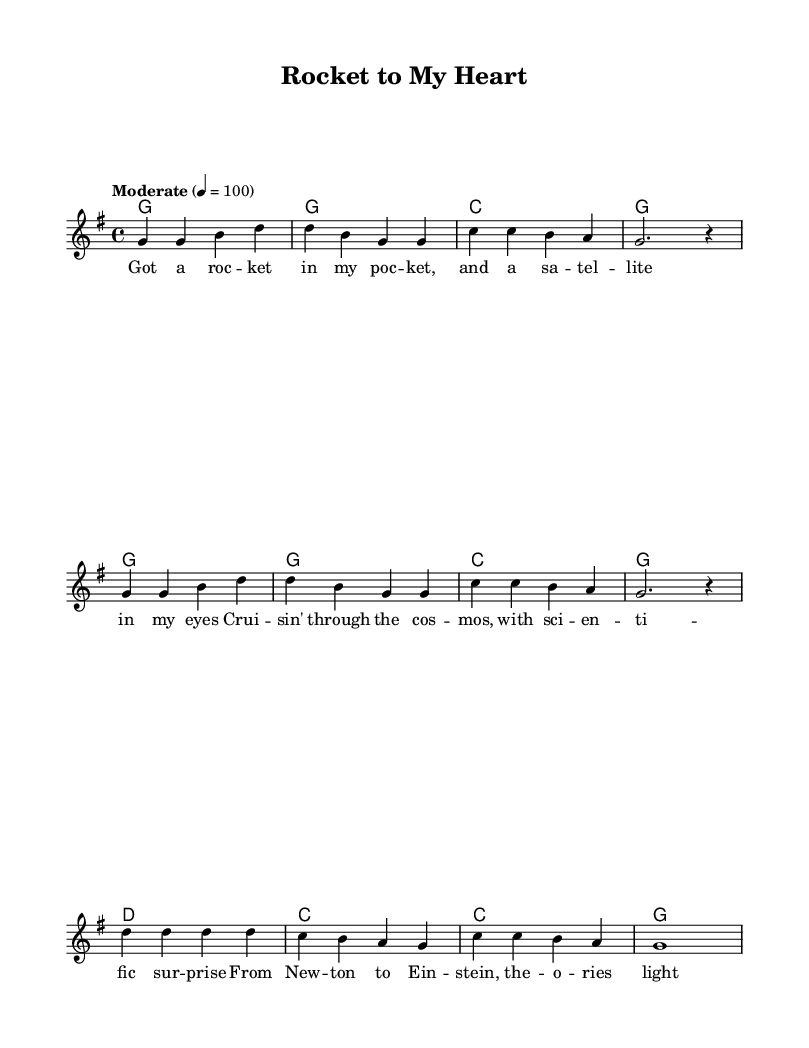What is the key signature of this music? The key signature is G major, as indicated by the presence of one sharp (F#) at the beginning of the score.
Answer: G major What is the time signature of the music? The time signature is 4/4, denoting that there are four beats in each measure and the quarter note gets one beat, which is shown in the second measure of the score.
Answer: 4/4 What is the tempo marking for the song? The tempo marking at the beginning of the score indicates "Moderate" with a metronome marking of 100 beats per minute. This guides the performer on the speed of the music.
Answer: Moderate 4 = 100 How many measures are in the melody? The melody consists of a total of 8 measures, as counted by the distinct sets of musical notes and rests laid out across the score.
Answer: 8 measures What is the lyrical theme of the first verse? The lyrics contain themes of space travel and scientific discovery, as suggested by lines mentioning a "rocket," "satellite," and references to famous scientists.
Answer: Space travel and scientific discovery What chord follows the first melody note in the score? The first melody note is a "G" note, and it is accompanied by a G major chord, as seen in the harmonies below the melody line indicating the chords played.
Answer: G major chord Which scientist is mentioned in the lyrics? The lyrics reference Newton and Einstein, two significant figures in the field of physics, highlighting their theories and contributions to science.
Answer: Newton and Einstein 